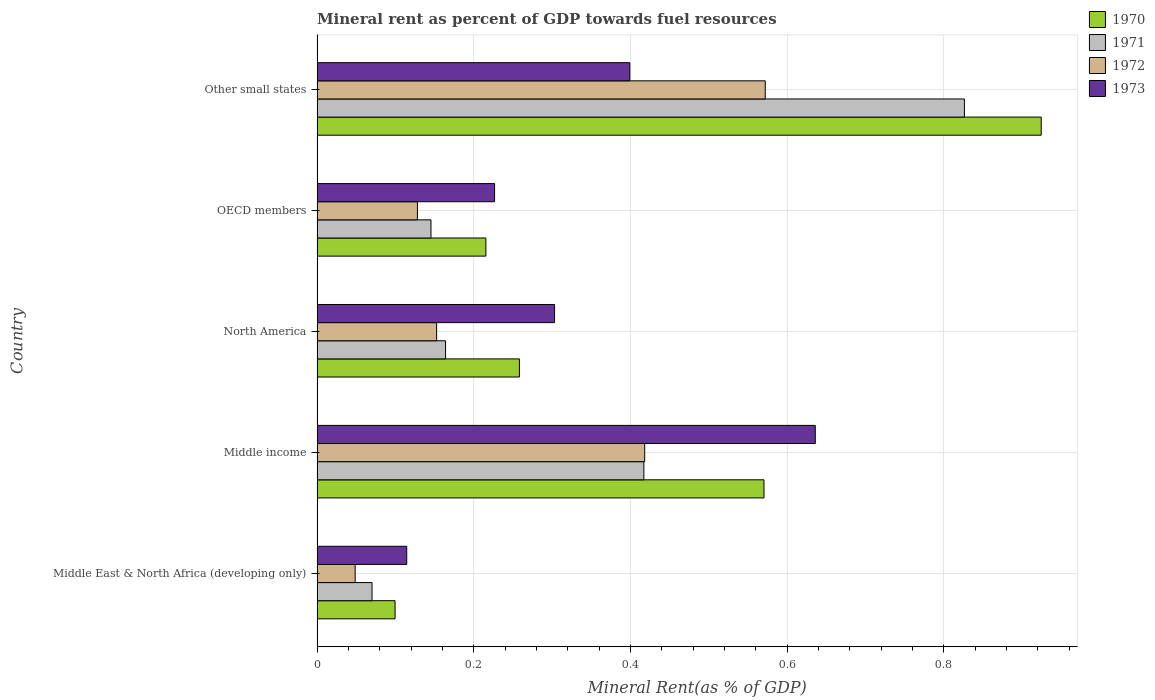How many groups of bars are there?
Your response must be concise. 5. Are the number of bars per tick equal to the number of legend labels?
Give a very brief answer. Yes. Are the number of bars on each tick of the Y-axis equal?
Provide a short and direct response. Yes. How many bars are there on the 5th tick from the top?
Your answer should be compact. 4. What is the mineral rent in 1970 in Middle East & North Africa (developing only)?
Keep it short and to the point. 0.1. Across all countries, what is the maximum mineral rent in 1971?
Your answer should be compact. 0.83. Across all countries, what is the minimum mineral rent in 1970?
Offer a terse response. 0.1. In which country was the mineral rent in 1972 maximum?
Offer a terse response. Other small states. In which country was the mineral rent in 1970 minimum?
Make the answer very short. Middle East & North Africa (developing only). What is the total mineral rent in 1971 in the graph?
Give a very brief answer. 1.62. What is the difference between the mineral rent in 1970 in Middle East & North Africa (developing only) and that in Other small states?
Ensure brevity in your answer.  -0.82. What is the difference between the mineral rent in 1971 in Middle income and the mineral rent in 1972 in North America?
Ensure brevity in your answer.  0.26. What is the average mineral rent in 1971 per country?
Your answer should be very brief. 0.32. What is the difference between the mineral rent in 1971 and mineral rent in 1972 in North America?
Give a very brief answer. 0.01. In how many countries, is the mineral rent in 1970 greater than 0.6000000000000001 %?
Ensure brevity in your answer.  1. What is the ratio of the mineral rent in 1970 in Middle East & North Africa (developing only) to that in North America?
Make the answer very short. 0.39. Is the mineral rent in 1970 in North America less than that in OECD members?
Keep it short and to the point. No. Is the difference between the mineral rent in 1971 in North America and Other small states greater than the difference between the mineral rent in 1972 in North America and Other small states?
Give a very brief answer. No. What is the difference between the highest and the second highest mineral rent in 1971?
Offer a terse response. 0.41. What is the difference between the highest and the lowest mineral rent in 1971?
Ensure brevity in your answer.  0.76. In how many countries, is the mineral rent in 1971 greater than the average mineral rent in 1971 taken over all countries?
Offer a terse response. 2. Is the sum of the mineral rent in 1973 in Middle East & North Africa (developing only) and North America greater than the maximum mineral rent in 1970 across all countries?
Offer a terse response. No. Is it the case that in every country, the sum of the mineral rent in 1973 and mineral rent in 1971 is greater than the sum of mineral rent in 1970 and mineral rent in 1972?
Provide a succinct answer. No. What does the 2nd bar from the bottom in Middle income represents?
Provide a short and direct response. 1971. How many bars are there?
Make the answer very short. 20. How many countries are there in the graph?
Keep it short and to the point. 5. Does the graph contain any zero values?
Ensure brevity in your answer.  No. Where does the legend appear in the graph?
Your answer should be very brief. Top right. How many legend labels are there?
Provide a succinct answer. 4. What is the title of the graph?
Ensure brevity in your answer.  Mineral rent as percent of GDP towards fuel resources. What is the label or title of the X-axis?
Offer a very short reply. Mineral Rent(as % of GDP). What is the Mineral Rent(as % of GDP) of 1970 in Middle East & North Africa (developing only)?
Ensure brevity in your answer.  0.1. What is the Mineral Rent(as % of GDP) of 1971 in Middle East & North Africa (developing only)?
Offer a very short reply. 0.07. What is the Mineral Rent(as % of GDP) in 1972 in Middle East & North Africa (developing only)?
Your response must be concise. 0.05. What is the Mineral Rent(as % of GDP) of 1973 in Middle East & North Africa (developing only)?
Your response must be concise. 0.11. What is the Mineral Rent(as % of GDP) of 1970 in Middle income?
Give a very brief answer. 0.57. What is the Mineral Rent(as % of GDP) in 1971 in Middle income?
Ensure brevity in your answer.  0.42. What is the Mineral Rent(as % of GDP) in 1972 in Middle income?
Provide a succinct answer. 0.42. What is the Mineral Rent(as % of GDP) in 1973 in Middle income?
Make the answer very short. 0.64. What is the Mineral Rent(as % of GDP) in 1970 in North America?
Your response must be concise. 0.26. What is the Mineral Rent(as % of GDP) in 1971 in North America?
Offer a terse response. 0.16. What is the Mineral Rent(as % of GDP) of 1972 in North America?
Your answer should be very brief. 0.15. What is the Mineral Rent(as % of GDP) of 1973 in North America?
Provide a short and direct response. 0.3. What is the Mineral Rent(as % of GDP) in 1970 in OECD members?
Your answer should be compact. 0.22. What is the Mineral Rent(as % of GDP) of 1971 in OECD members?
Give a very brief answer. 0.15. What is the Mineral Rent(as % of GDP) of 1972 in OECD members?
Offer a terse response. 0.13. What is the Mineral Rent(as % of GDP) of 1973 in OECD members?
Your response must be concise. 0.23. What is the Mineral Rent(as % of GDP) in 1970 in Other small states?
Give a very brief answer. 0.92. What is the Mineral Rent(as % of GDP) in 1971 in Other small states?
Your answer should be compact. 0.83. What is the Mineral Rent(as % of GDP) of 1972 in Other small states?
Ensure brevity in your answer.  0.57. What is the Mineral Rent(as % of GDP) of 1973 in Other small states?
Offer a very short reply. 0.4. Across all countries, what is the maximum Mineral Rent(as % of GDP) of 1970?
Ensure brevity in your answer.  0.92. Across all countries, what is the maximum Mineral Rent(as % of GDP) in 1971?
Ensure brevity in your answer.  0.83. Across all countries, what is the maximum Mineral Rent(as % of GDP) of 1972?
Offer a very short reply. 0.57. Across all countries, what is the maximum Mineral Rent(as % of GDP) of 1973?
Offer a very short reply. 0.64. Across all countries, what is the minimum Mineral Rent(as % of GDP) of 1970?
Your response must be concise. 0.1. Across all countries, what is the minimum Mineral Rent(as % of GDP) of 1971?
Keep it short and to the point. 0.07. Across all countries, what is the minimum Mineral Rent(as % of GDP) of 1972?
Make the answer very short. 0.05. Across all countries, what is the minimum Mineral Rent(as % of GDP) in 1973?
Give a very brief answer. 0.11. What is the total Mineral Rent(as % of GDP) of 1970 in the graph?
Provide a succinct answer. 2.07. What is the total Mineral Rent(as % of GDP) in 1971 in the graph?
Offer a terse response. 1.62. What is the total Mineral Rent(as % of GDP) in 1972 in the graph?
Your answer should be very brief. 1.32. What is the total Mineral Rent(as % of GDP) of 1973 in the graph?
Provide a succinct answer. 1.68. What is the difference between the Mineral Rent(as % of GDP) in 1970 in Middle East & North Africa (developing only) and that in Middle income?
Offer a terse response. -0.47. What is the difference between the Mineral Rent(as % of GDP) of 1971 in Middle East & North Africa (developing only) and that in Middle income?
Ensure brevity in your answer.  -0.35. What is the difference between the Mineral Rent(as % of GDP) of 1972 in Middle East & North Africa (developing only) and that in Middle income?
Your response must be concise. -0.37. What is the difference between the Mineral Rent(as % of GDP) in 1973 in Middle East & North Africa (developing only) and that in Middle income?
Keep it short and to the point. -0.52. What is the difference between the Mineral Rent(as % of GDP) in 1970 in Middle East & North Africa (developing only) and that in North America?
Offer a very short reply. -0.16. What is the difference between the Mineral Rent(as % of GDP) in 1971 in Middle East & North Africa (developing only) and that in North America?
Offer a terse response. -0.09. What is the difference between the Mineral Rent(as % of GDP) of 1972 in Middle East & North Africa (developing only) and that in North America?
Offer a very short reply. -0.1. What is the difference between the Mineral Rent(as % of GDP) in 1973 in Middle East & North Africa (developing only) and that in North America?
Give a very brief answer. -0.19. What is the difference between the Mineral Rent(as % of GDP) of 1970 in Middle East & North Africa (developing only) and that in OECD members?
Provide a succinct answer. -0.12. What is the difference between the Mineral Rent(as % of GDP) in 1971 in Middle East & North Africa (developing only) and that in OECD members?
Keep it short and to the point. -0.08. What is the difference between the Mineral Rent(as % of GDP) in 1972 in Middle East & North Africa (developing only) and that in OECD members?
Give a very brief answer. -0.08. What is the difference between the Mineral Rent(as % of GDP) in 1973 in Middle East & North Africa (developing only) and that in OECD members?
Make the answer very short. -0.11. What is the difference between the Mineral Rent(as % of GDP) in 1970 in Middle East & North Africa (developing only) and that in Other small states?
Your response must be concise. -0.82. What is the difference between the Mineral Rent(as % of GDP) of 1971 in Middle East & North Africa (developing only) and that in Other small states?
Ensure brevity in your answer.  -0.76. What is the difference between the Mineral Rent(as % of GDP) of 1972 in Middle East & North Africa (developing only) and that in Other small states?
Offer a very short reply. -0.52. What is the difference between the Mineral Rent(as % of GDP) of 1973 in Middle East & North Africa (developing only) and that in Other small states?
Keep it short and to the point. -0.28. What is the difference between the Mineral Rent(as % of GDP) of 1970 in Middle income and that in North America?
Keep it short and to the point. 0.31. What is the difference between the Mineral Rent(as % of GDP) of 1971 in Middle income and that in North America?
Give a very brief answer. 0.25. What is the difference between the Mineral Rent(as % of GDP) of 1972 in Middle income and that in North America?
Provide a succinct answer. 0.27. What is the difference between the Mineral Rent(as % of GDP) of 1973 in Middle income and that in North America?
Ensure brevity in your answer.  0.33. What is the difference between the Mineral Rent(as % of GDP) in 1970 in Middle income and that in OECD members?
Make the answer very short. 0.35. What is the difference between the Mineral Rent(as % of GDP) of 1971 in Middle income and that in OECD members?
Offer a very short reply. 0.27. What is the difference between the Mineral Rent(as % of GDP) of 1972 in Middle income and that in OECD members?
Make the answer very short. 0.29. What is the difference between the Mineral Rent(as % of GDP) in 1973 in Middle income and that in OECD members?
Provide a succinct answer. 0.41. What is the difference between the Mineral Rent(as % of GDP) in 1970 in Middle income and that in Other small states?
Ensure brevity in your answer.  -0.35. What is the difference between the Mineral Rent(as % of GDP) in 1971 in Middle income and that in Other small states?
Give a very brief answer. -0.41. What is the difference between the Mineral Rent(as % of GDP) of 1972 in Middle income and that in Other small states?
Ensure brevity in your answer.  -0.15. What is the difference between the Mineral Rent(as % of GDP) in 1973 in Middle income and that in Other small states?
Your answer should be compact. 0.24. What is the difference between the Mineral Rent(as % of GDP) of 1970 in North America and that in OECD members?
Provide a succinct answer. 0.04. What is the difference between the Mineral Rent(as % of GDP) of 1971 in North America and that in OECD members?
Your answer should be very brief. 0.02. What is the difference between the Mineral Rent(as % of GDP) of 1972 in North America and that in OECD members?
Provide a succinct answer. 0.02. What is the difference between the Mineral Rent(as % of GDP) of 1973 in North America and that in OECD members?
Your response must be concise. 0.08. What is the difference between the Mineral Rent(as % of GDP) in 1970 in North America and that in Other small states?
Give a very brief answer. -0.67. What is the difference between the Mineral Rent(as % of GDP) of 1971 in North America and that in Other small states?
Your answer should be very brief. -0.66. What is the difference between the Mineral Rent(as % of GDP) in 1972 in North America and that in Other small states?
Your answer should be compact. -0.42. What is the difference between the Mineral Rent(as % of GDP) of 1973 in North America and that in Other small states?
Your answer should be compact. -0.1. What is the difference between the Mineral Rent(as % of GDP) in 1970 in OECD members and that in Other small states?
Keep it short and to the point. -0.71. What is the difference between the Mineral Rent(as % of GDP) in 1971 in OECD members and that in Other small states?
Keep it short and to the point. -0.68. What is the difference between the Mineral Rent(as % of GDP) of 1972 in OECD members and that in Other small states?
Your answer should be compact. -0.44. What is the difference between the Mineral Rent(as % of GDP) in 1973 in OECD members and that in Other small states?
Your response must be concise. -0.17. What is the difference between the Mineral Rent(as % of GDP) in 1970 in Middle East & North Africa (developing only) and the Mineral Rent(as % of GDP) in 1971 in Middle income?
Offer a terse response. -0.32. What is the difference between the Mineral Rent(as % of GDP) of 1970 in Middle East & North Africa (developing only) and the Mineral Rent(as % of GDP) of 1972 in Middle income?
Your response must be concise. -0.32. What is the difference between the Mineral Rent(as % of GDP) of 1970 in Middle East & North Africa (developing only) and the Mineral Rent(as % of GDP) of 1973 in Middle income?
Ensure brevity in your answer.  -0.54. What is the difference between the Mineral Rent(as % of GDP) in 1971 in Middle East & North Africa (developing only) and the Mineral Rent(as % of GDP) in 1972 in Middle income?
Provide a short and direct response. -0.35. What is the difference between the Mineral Rent(as % of GDP) in 1971 in Middle East & North Africa (developing only) and the Mineral Rent(as % of GDP) in 1973 in Middle income?
Offer a terse response. -0.57. What is the difference between the Mineral Rent(as % of GDP) in 1972 in Middle East & North Africa (developing only) and the Mineral Rent(as % of GDP) in 1973 in Middle income?
Give a very brief answer. -0.59. What is the difference between the Mineral Rent(as % of GDP) in 1970 in Middle East & North Africa (developing only) and the Mineral Rent(as % of GDP) in 1971 in North America?
Make the answer very short. -0.06. What is the difference between the Mineral Rent(as % of GDP) in 1970 in Middle East & North Africa (developing only) and the Mineral Rent(as % of GDP) in 1972 in North America?
Make the answer very short. -0.05. What is the difference between the Mineral Rent(as % of GDP) of 1970 in Middle East & North Africa (developing only) and the Mineral Rent(as % of GDP) of 1973 in North America?
Make the answer very short. -0.2. What is the difference between the Mineral Rent(as % of GDP) in 1971 in Middle East & North Africa (developing only) and the Mineral Rent(as % of GDP) in 1972 in North America?
Give a very brief answer. -0.08. What is the difference between the Mineral Rent(as % of GDP) in 1971 in Middle East & North Africa (developing only) and the Mineral Rent(as % of GDP) in 1973 in North America?
Offer a terse response. -0.23. What is the difference between the Mineral Rent(as % of GDP) in 1972 in Middle East & North Africa (developing only) and the Mineral Rent(as % of GDP) in 1973 in North America?
Provide a succinct answer. -0.25. What is the difference between the Mineral Rent(as % of GDP) of 1970 in Middle East & North Africa (developing only) and the Mineral Rent(as % of GDP) of 1971 in OECD members?
Provide a succinct answer. -0.05. What is the difference between the Mineral Rent(as % of GDP) of 1970 in Middle East & North Africa (developing only) and the Mineral Rent(as % of GDP) of 1972 in OECD members?
Your answer should be very brief. -0.03. What is the difference between the Mineral Rent(as % of GDP) in 1970 in Middle East & North Africa (developing only) and the Mineral Rent(as % of GDP) in 1973 in OECD members?
Give a very brief answer. -0.13. What is the difference between the Mineral Rent(as % of GDP) in 1971 in Middle East & North Africa (developing only) and the Mineral Rent(as % of GDP) in 1972 in OECD members?
Keep it short and to the point. -0.06. What is the difference between the Mineral Rent(as % of GDP) of 1971 in Middle East & North Africa (developing only) and the Mineral Rent(as % of GDP) of 1973 in OECD members?
Your answer should be very brief. -0.16. What is the difference between the Mineral Rent(as % of GDP) in 1972 in Middle East & North Africa (developing only) and the Mineral Rent(as % of GDP) in 1973 in OECD members?
Offer a terse response. -0.18. What is the difference between the Mineral Rent(as % of GDP) in 1970 in Middle East & North Africa (developing only) and the Mineral Rent(as % of GDP) in 1971 in Other small states?
Your answer should be compact. -0.73. What is the difference between the Mineral Rent(as % of GDP) in 1970 in Middle East & North Africa (developing only) and the Mineral Rent(as % of GDP) in 1972 in Other small states?
Your answer should be very brief. -0.47. What is the difference between the Mineral Rent(as % of GDP) of 1970 in Middle East & North Africa (developing only) and the Mineral Rent(as % of GDP) of 1973 in Other small states?
Your response must be concise. -0.3. What is the difference between the Mineral Rent(as % of GDP) in 1971 in Middle East & North Africa (developing only) and the Mineral Rent(as % of GDP) in 1972 in Other small states?
Offer a terse response. -0.5. What is the difference between the Mineral Rent(as % of GDP) in 1971 in Middle East & North Africa (developing only) and the Mineral Rent(as % of GDP) in 1973 in Other small states?
Offer a very short reply. -0.33. What is the difference between the Mineral Rent(as % of GDP) of 1972 in Middle East & North Africa (developing only) and the Mineral Rent(as % of GDP) of 1973 in Other small states?
Provide a short and direct response. -0.35. What is the difference between the Mineral Rent(as % of GDP) of 1970 in Middle income and the Mineral Rent(as % of GDP) of 1971 in North America?
Provide a succinct answer. 0.41. What is the difference between the Mineral Rent(as % of GDP) in 1970 in Middle income and the Mineral Rent(as % of GDP) in 1972 in North America?
Make the answer very short. 0.42. What is the difference between the Mineral Rent(as % of GDP) of 1970 in Middle income and the Mineral Rent(as % of GDP) of 1973 in North America?
Provide a short and direct response. 0.27. What is the difference between the Mineral Rent(as % of GDP) of 1971 in Middle income and the Mineral Rent(as % of GDP) of 1972 in North America?
Your answer should be very brief. 0.26. What is the difference between the Mineral Rent(as % of GDP) in 1971 in Middle income and the Mineral Rent(as % of GDP) in 1973 in North America?
Offer a very short reply. 0.11. What is the difference between the Mineral Rent(as % of GDP) of 1972 in Middle income and the Mineral Rent(as % of GDP) of 1973 in North America?
Give a very brief answer. 0.12. What is the difference between the Mineral Rent(as % of GDP) in 1970 in Middle income and the Mineral Rent(as % of GDP) in 1971 in OECD members?
Your answer should be compact. 0.43. What is the difference between the Mineral Rent(as % of GDP) of 1970 in Middle income and the Mineral Rent(as % of GDP) of 1972 in OECD members?
Your answer should be very brief. 0.44. What is the difference between the Mineral Rent(as % of GDP) of 1970 in Middle income and the Mineral Rent(as % of GDP) of 1973 in OECD members?
Your answer should be compact. 0.34. What is the difference between the Mineral Rent(as % of GDP) of 1971 in Middle income and the Mineral Rent(as % of GDP) of 1972 in OECD members?
Offer a very short reply. 0.29. What is the difference between the Mineral Rent(as % of GDP) of 1971 in Middle income and the Mineral Rent(as % of GDP) of 1973 in OECD members?
Provide a short and direct response. 0.19. What is the difference between the Mineral Rent(as % of GDP) in 1972 in Middle income and the Mineral Rent(as % of GDP) in 1973 in OECD members?
Your answer should be very brief. 0.19. What is the difference between the Mineral Rent(as % of GDP) in 1970 in Middle income and the Mineral Rent(as % of GDP) in 1971 in Other small states?
Give a very brief answer. -0.26. What is the difference between the Mineral Rent(as % of GDP) of 1970 in Middle income and the Mineral Rent(as % of GDP) of 1972 in Other small states?
Keep it short and to the point. -0. What is the difference between the Mineral Rent(as % of GDP) of 1970 in Middle income and the Mineral Rent(as % of GDP) of 1973 in Other small states?
Your response must be concise. 0.17. What is the difference between the Mineral Rent(as % of GDP) of 1971 in Middle income and the Mineral Rent(as % of GDP) of 1972 in Other small states?
Offer a terse response. -0.15. What is the difference between the Mineral Rent(as % of GDP) in 1971 in Middle income and the Mineral Rent(as % of GDP) in 1973 in Other small states?
Give a very brief answer. 0.02. What is the difference between the Mineral Rent(as % of GDP) of 1972 in Middle income and the Mineral Rent(as % of GDP) of 1973 in Other small states?
Offer a terse response. 0.02. What is the difference between the Mineral Rent(as % of GDP) in 1970 in North America and the Mineral Rent(as % of GDP) in 1971 in OECD members?
Provide a short and direct response. 0.11. What is the difference between the Mineral Rent(as % of GDP) in 1970 in North America and the Mineral Rent(as % of GDP) in 1972 in OECD members?
Your answer should be very brief. 0.13. What is the difference between the Mineral Rent(as % of GDP) in 1970 in North America and the Mineral Rent(as % of GDP) in 1973 in OECD members?
Your answer should be compact. 0.03. What is the difference between the Mineral Rent(as % of GDP) in 1971 in North America and the Mineral Rent(as % of GDP) in 1972 in OECD members?
Your answer should be very brief. 0.04. What is the difference between the Mineral Rent(as % of GDP) of 1971 in North America and the Mineral Rent(as % of GDP) of 1973 in OECD members?
Ensure brevity in your answer.  -0.06. What is the difference between the Mineral Rent(as % of GDP) in 1972 in North America and the Mineral Rent(as % of GDP) in 1973 in OECD members?
Offer a terse response. -0.07. What is the difference between the Mineral Rent(as % of GDP) in 1970 in North America and the Mineral Rent(as % of GDP) in 1971 in Other small states?
Make the answer very short. -0.57. What is the difference between the Mineral Rent(as % of GDP) of 1970 in North America and the Mineral Rent(as % of GDP) of 1972 in Other small states?
Ensure brevity in your answer.  -0.31. What is the difference between the Mineral Rent(as % of GDP) in 1970 in North America and the Mineral Rent(as % of GDP) in 1973 in Other small states?
Your answer should be compact. -0.14. What is the difference between the Mineral Rent(as % of GDP) of 1971 in North America and the Mineral Rent(as % of GDP) of 1972 in Other small states?
Your response must be concise. -0.41. What is the difference between the Mineral Rent(as % of GDP) of 1971 in North America and the Mineral Rent(as % of GDP) of 1973 in Other small states?
Your answer should be very brief. -0.24. What is the difference between the Mineral Rent(as % of GDP) of 1972 in North America and the Mineral Rent(as % of GDP) of 1973 in Other small states?
Ensure brevity in your answer.  -0.25. What is the difference between the Mineral Rent(as % of GDP) of 1970 in OECD members and the Mineral Rent(as % of GDP) of 1971 in Other small states?
Your answer should be compact. -0.61. What is the difference between the Mineral Rent(as % of GDP) of 1970 in OECD members and the Mineral Rent(as % of GDP) of 1972 in Other small states?
Offer a terse response. -0.36. What is the difference between the Mineral Rent(as % of GDP) in 1970 in OECD members and the Mineral Rent(as % of GDP) in 1973 in Other small states?
Ensure brevity in your answer.  -0.18. What is the difference between the Mineral Rent(as % of GDP) of 1971 in OECD members and the Mineral Rent(as % of GDP) of 1972 in Other small states?
Keep it short and to the point. -0.43. What is the difference between the Mineral Rent(as % of GDP) in 1971 in OECD members and the Mineral Rent(as % of GDP) in 1973 in Other small states?
Make the answer very short. -0.25. What is the difference between the Mineral Rent(as % of GDP) in 1972 in OECD members and the Mineral Rent(as % of GDP) in 1973 in Other small states?
Your answer should be very brief. -0.27. What is the average Mineral Rent(as % of GDP) of 1970 per country?
Your answer should be very brief. 0.41. What is the average Mineral Rent(as % of GDP) of 1971 per country?
Offer a very short reply. 0.32. What is the average Mineral Rent(as % of GDP) in 1972 per country?
Provide a short and direct response. 0.26. What is the average Mineral Rent(as % of GDP) of 1973 per country?
Offer a terse response. 0.34. What is the difference between the Mineral Rent(as % of GDP) in 1970 and Mineral Rent(as % of GDP) in 1971 in Middle East & North Africa (developing only)?
Ensure brevity in your answer.  0.03. What is the difference between the Mineral Rent(as % of GDP) in 1970 and Mineral Rent(as % of GDP) in 1972 in Middle East & North Africa (developing only)?
Keep it short and to the point. 0.05. What is the difference between the Mineral Rent(as % of GDP) of 1970 and Mineral Rent(as % of GDP) of 1973 in Middle East & North Africa (developing only)?
Give a very brief answer. -0.01. What is the difference between the Mineral Rent(as % of GDP) in 1971 and Mineral Rent(as % of GDP) in 1972 in Middle East & North Africa (developing only)?
Your response must be concise. 0.02. What is the difference between the Mineral Rent(as % of GDP) of 1971 and Mineral Rent(as % of GDP) of 1973 in Middle East & North Africa (developing only)?
Ensure brevity in your answer.  -0.04. What is the difference between the Mineral Rent(as % of GDP) in 1972 and Mineral Rent(as % of GDP) in 1973 in Middle East & North Africa (developing only)?
Your response must be concise. -0.07. What is the difference between the Mineral Rent(as % of GDP) of 1970 and Mineral Rent(as % of GDP) of 1971 in Middle income?
Make the answer very short. 0.15. What is the difference between the Mineral Rent(as % of GDP) in 1970 and Mineral Rent(as % of GDP) in 1972 in Middle income?
Provide a short and direct response. 0.15. What is the difference between the Mineral Rent(as % of GDP) in 1970 and Mineral Rent(as % of GDP) in 1973 in Middle income?
Offer a very short reply. -0.07. What is the difference between the Mineral Rent(as % of GDP) in 1971 and Mineral Rent(as % of GDP) in 1972 in Middle income?
Give a very brief answer. -0. What is the difference between the Mineral Rent(as % of GDP) in 1971 and Mineral Rent(as % of GDP) in 1973 in Middle income?
Keep it short and to the point. -0.22. What is the difference between the Mineral Rent(as % of GDP) of 1972 and Mineral Rent(as % of GDP) of 1973 in Middle income?
Provide a succinct answer. -0.22. What is the difference between the Mineral Rent(as % of GDP) in 1970 and Mineral Rent(as % of GDP) in 1971 in North America?
Make the answer very short. 0.09. What is the difference between the Mineral Rent(as % of GDP) in 1970 and Mineral Rent(as % of GDP) in 1972 in North America?
Your answer should be very brief. 0.11. What is the difference between the Mineral Rent(as % of GDP) of 1970 and Mineral Rent(as % of GDP) of 1973 in North America?
Make the answer very short. -0.04. What is the difference between the Mineral Rent(as % of GDP) of 1971 and Mineral Rent(as % of GDP) of 1972 in North America?
Provide a short and direct response. 0.01. What is the difference between the Mineral Rent(as % of GDP) of 1971 and Mineral Rent(as % of GDP) of 1973 in North America?
Offer a terse response. -0.14. What is the difference between the Mineral Rent(as % of GDP) of 1972 and Mineral Rent(as % of GDP) of 1973 in North America?
Keep it short and to the point. -0.15. What is the difference between the Mineral Rent(as % of GDP) of 1970 and Mineral Rent(as % of GDP) of 1971 in OECD members?
Give a very brief answer. 0.07. What is the difference between the Mineral Rent(as % of GDP) of 1970 and Mineral Rent(as % of GDP) of 1972 in OECD members?
Provide a short and direct response. 0.09. What is the difference between the Mineral Rent(as % of GDP) in 1970 and Mineral Rent(as % of GDP) in 1973 in OECD members?
Your answer should be very brief. -0.01. What is the difference between the Mineral Rent(as % of GDP) in 1971 and Mineral Rent(as % of GDP) in 1972 in OECD members?
Offer a very short reply. 0.02. What is the difference between the Mineral Rent(as % of GDP) in 1971 and Mineral Rent(as % of GDP) in 1973 in OECD members?
Give a very brief answer. -0.08. What is the difference between the Mineral Rent(as % of GDP) in 1972 and Mineral Rent(as % of GDP) in 1973 in OECD members?
Make the answer very short. -0.1. What is the difference between the Mineral Rent(as % of GDP) of 1970 and Mineral Rent(as % of GDP) of 1971 in Other small states?
Your answer should be very brief. 0.1. What is the difference between the Mineral Rent(as % of GDP) of 1970 and Mineral Rent(as % of GDP) of 1972 in Other small states?
Keep it short and to the point. 0.35. What is the difference between the Mineral Rent(as % of GDP) of 1970 and Mineral Rent(as % of GDP) of 1973 in Other small states?
Offer a terse response. 0.53. What is the difference between the Mineral Rent(as % of GDP) in 1971 and Mineral Rent(as % of GDP) in 1972 in Other small states?
Provide a short and direct response. 0.25. What is the difference between the Mineral Rent(as % of GDP) of 1971 and Mineral Rent(as % of GDP) of 1973 in Other small states?
Provide a succinct answer. 0.43. What is the difference between the Mineral Rent(as % of GDP) of 1972 and Mineral Rent(as % of GDP) of 1973 in Other small states?
Offer a terse response. 0.17. What is the ratio of the Mineral Rent(as % of GDP) in 1970 in Middle East & North Africa (developing only) to that in Middle income?
Offer a terse response. 0.17. What is the ratio of the Mineral Rent(as % of GDP) in 1971 in Middle East & North Africa (developing only) to that in Middle income?
Offer a very short reply. 0.17. What is the ratio of the Mineral Rent(as % of GDP) in 1972 in Middle East & North Africa (developing only) to that in Middle income?
Make the answer very short. 0.12. What is the ratio of the Mineral Rent(as % of GDP) of 1973 in Middle East & North Africa (developing only) to that in Middle income?
Your answer should be very brief. 0.18. What is the ratio of the Mineral Rent(as % of GDP) in 1970 in Middle East & North Africa (developing only) to that in North America?
Give a very brief answer. 0.39. What is the ratio of the Mineral Rent(as % of GDP) in 1971 in Middle East & North Africa (developing only) to that in North America?
Provide a succinct answer. 0.43. What is the ratio of the Mineral Rent(as % of GDP) in 1972 in Middle East & North Africa (developing only) to that in North America?
Offer a terse response. 0.32. What is the ratio of the Mineral Rent(as % of GDP) of 1973 in Middle East & North Africa (developing only) to that in North America?
Your answer should be compact. 0.38. What is the ratio of the Mineral Rent(as % of GDP) of 1970 in Middle East & North Africa (developing only) to that in OECD members?
Your answer should be compact. 0.46. What is the ratio of the Mineral Rent(as % of GDP) of 1971 in Middle East & North Africa (developing only) to that in OECD members?
Offer a very short reply. 0.48. What is the ratio of the Mineral Rent(as % of GDP) of 1972 in Middle East & North Africa (developing only) to that in OECD members?
Ensure brevity in your answer.  0.38. What is the ratio of the Mineral Rent(as % of GDP) of 1973 in Middle East & North Africa (developing only) to that in OECD members?
Your answer should be very brief. 0.51. What is the ratio of the Mineral Rent(as % of GDP) of 1970 in Middle East & North Africa (developing only) to that in Other small states?
Your response must be concise. 0.11. What is the ratio of the Mineral Rent(as % of GDP) of 1971 in Middle East & North Africa (developing only) to that in Other small states?
Your response must be concise. 0.08. What is the ratio of the Mineral Rent(as % of GDP) of 1972 in Middle East & North Africa (developing only) to that in Other small states?
Your response must be concise. 0.09. What is the ratio of the Mineral Rent(as % of GDP) in 1973 in Middle East & North Africa (developing only) to that in Other small states?
Your response must be concise. 0.29. What is the ratio of the Mineral Rent(as % of GDP) in 1970 in Middle income to that in North America?
Your answer should be very brief. 2.21. What is the ratio of the Mineral Rent(as % of GDP) of 1971 in Middle income to that in North America?
Keep it short and to the point. 2.54. What is the ratio of the Mineral Rent(as % of GDP) of 1972 in Middle income to that in North America?
Make the answer very short. 2.74. What is the ratio of the Mineral Rent(as % of GDP) in 1973 in Middle income to that in North America?
Provide a short and direct response. 2.1. What is the ratio of the Mineral Rent(as % of GDP) in 1970 in Middle income to that in OECD members?
Provide a short and direct response. 2.65. What is the ratio of the Mineral Rent(as % of GDP) in 1971 in Middle income to that in OECD members?
Your answer should be compact. 2.87. What is the ratio of the Mineral Rent(as % of GDP) in 1972 in Middle income to that in OECD members?
Provide a succinct answer. 3.26. What is the ratio of the Mineral Rent(as % of GDP) of 1973 in Middle income to that in OECD members?
Provide a succinct answer. 2.81. What is the ratio of the Mineral Rent(as % of GDP) of 1970 in Middle income to that in Other small states?
Give a very brief answer. 0.62. What is the ratio of the Mineral Rent(as % of GDP) in 1971 in Middle income to that in Other small states?
Your response must be concise. 0.5. What is the ratio of the Mineral Rent(as % of GDP) in 1972 in Middle income to that in Other small states?
Your response must be concise. 0.73. What is the ratio of the Mineral Rent(as % of GDP) of 1973 in Middle income to that in Other small states?
Keep it short and to the point. 1.59. What is the ratio of the Mineral Rent(as % of GDP) in 1970 in North America to that in OECD members?
Provide a short and direct response. 1.2. What is the ratio of the Mineral Rent(as % of GDP) of 1971 in North America to that in OECD members?
Provide a succinct answer. 1.13. What is the ratio of the Mineral Rent(as % of GDP) in 1972 in North America to that in OECD members?
Make the answer very short. 1.19. What is the ratio of the Mineral Rent(as % of GDP) of 1973 in North America to that in OECD members?
Give a very brief answer. 1.34. What is the ratio of the Mineral Rent(as % of GDP) of 1970 in North America to that in Other small states?
Offer a terse response. 0.28. What is the ratio of the Mineral Rent(as % of GDP) of 1971 in North America to that in Other small states?
Your answer should be compact. 0.2. What is the ratio of the Mineral Rent(as % of GDP) in 1972 in North America to that in Other small states?
Your answer should be compact. 0.27. What is the ratio of the Mineral Rent(as % of GDP) of 1973 in North America to that in Other small states?
Provide a succinct answer. 0.76. What is the ratio of the Mineral Rent(as % of GDP) of 1970 in OECD members to that in Other small states?
Give a very brief answer. 0.23. What is the ratio of the Mineral Rent(as % of GDP) of 1971 in OECD members to that in Other small states?
Offer a very short reply. 0.18. What is the ratio of the Mineral Rent(as % of GDP) in 1972 in OECD members to that in Other small states?
Keep it short and to the point. 0.22. What is the ratio of the Mineral Rent(as % of GDP) in 1973 in OECD members to that in Other small states?
Your answer should be compact. 0.57. What is the difference between the highest and the second highest Mineral Rent(as % of GDP) of 1970?
Offer a very short reply. 0.35. What is the difference between the highest and the second highest Mineral Rent(as % of GDP) of 1971?
Offer a terse response. 0.41. What is the difference between the highest and the second highest Mineral Rent(as % of GDP) of 1972?
Make the answer very short. 0.15. What is the difference between the highest and the second highest Mineral Rent(as % of GDP) in 1973?
Provide a succinct answer. 0.24. What is the difference between the highest and the lowest Mineral Rent(as % of GDP) of 1970?
Provide a short and direct response. 0.82. What is the difference between the highest and the lowest Mineral Rent(as % of GDP) in 1971?
Give a very brief answer. 0.76. What is the difference between the highest and the lowest Mineral Rent(as % of GDP) of 1972?
Provide a short and direct response. 0.52. What is the difference between the highest and the lowest Mineral Rent(as % of GDP) in 1973?
Your answer should be very brief. 0.52. 